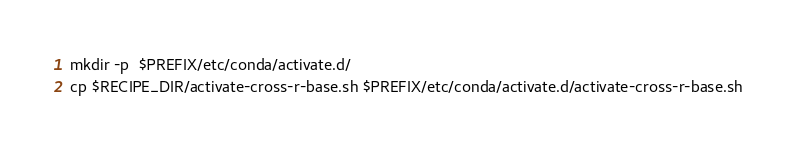<code> <loc_0><loc_0><loc_500><loc_500><_Bash_>mkdir -p  $PREFIX/etc/conda/activate.d/
cp $RECIPE_DIR/activate-cross-r-base.sh $PREFIX/etc/conda/activate.d/activate-cross-r-base.sh
</code> 